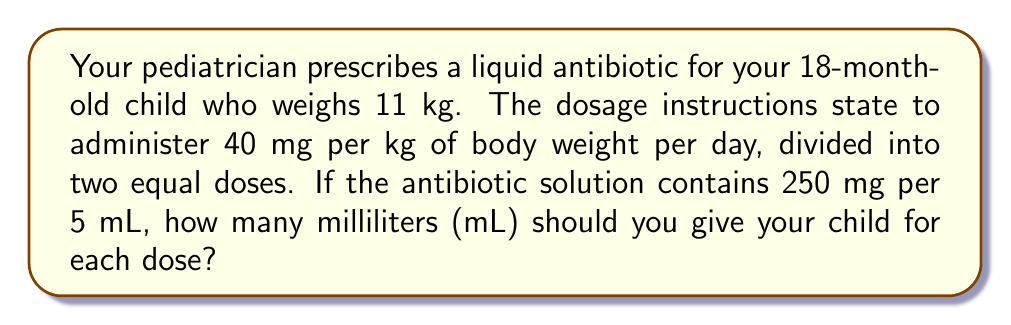Teach me how to tackle this problem. Let's break this down step-by-step:

1. Calculate the total daily dosage:
   $$ \text{Daily dosage} = 40 \text{ mg/kg} \times 11 \text{ kg} = 440 \text{ mg} $$

2. Divide the daily dosage into two equal doses:
   $$ \text{Single dose} = \frac{440 \text{ mg}}{2} = 220 \text{ mg} $$

3. Set up a proportion to convert mg to mL:
   $$ \frac{250 \text{ mg}}{5 \text{ mL}} = \frac{220 \text{ mg}}{x \text{ mL}} $$

4. Cross multiply:
   $$ 250x = 220 \times 5 $$

5. Solve for x:
   $$ x = \frac{220 \times 5}{250} = \frac{1100}{250} = 4.4 \text{ mL} $$

Therefore, you should administer 4.4 mL of the antibiotic solution for each dose.
Answer: 4.4 mL 